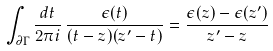<formula> <loc_0><loc_0><loc_500><loc_500>\int _ { \partial \Gamma } \frac { d t } { 2 \pi i } \, \frac { \epsilon ( t ) } { ( t - z ) ( z ^ { \prime } - t ) } = \frac { \epsilon ( z ) - \epsilon ( z ^ { \prime } ) } { z ^ { \prime } - z }</formula> 